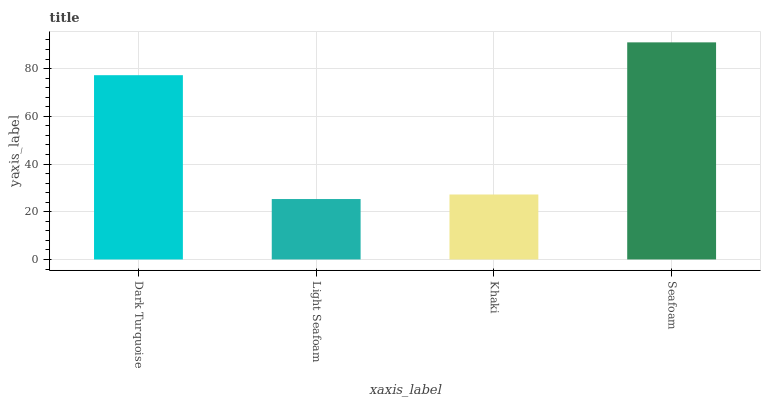Is Light Seafoam the minimum?
Answer yes or no. Yes. Is Seafoam the maximum?
Answer yes or no. Yes. Is Khaki the minimum?
Answer yes or no. No. Is Khaki the maximum?
Answer yes or no. No. Is Khaki greater than Light Seafoam?
Answer yes or no. Yes. Is Light Seafoam less than Khaki?
Answer yes or no. Yes. Is Light Seafoam greater than Khaki?
Answer yes or no. No. Is Khaki less than Light Seafoam?
Answer yes or no. No. Is Dark Turquoise the high median?
Answer yes or no. Yes. Is Khaki the low median?
Answer yes or no. Yes. Is Khaki the high median?
Answer yes or no. No. Is Dark Turquoise the low median?
Answer yes or no. No. 